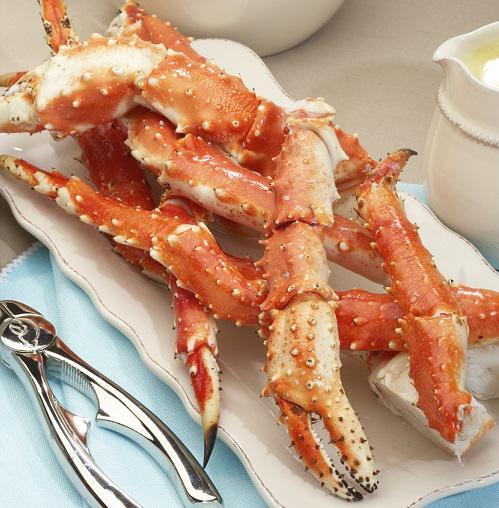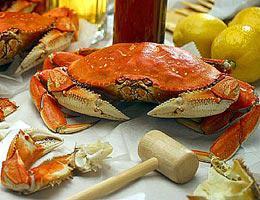The first image is the image on the left, the second image is the image on the right. Considering the images on both sides, is "there are two snow crab clusters on a white round plate" valid? Answer yes or no. No. The first image is the image on the left, the second image is the image on the right. Considering the images on both sides, is "One image shows long red crab legs connected by whitish meat served on a round white plate." valid? Answer yes or no. No. 